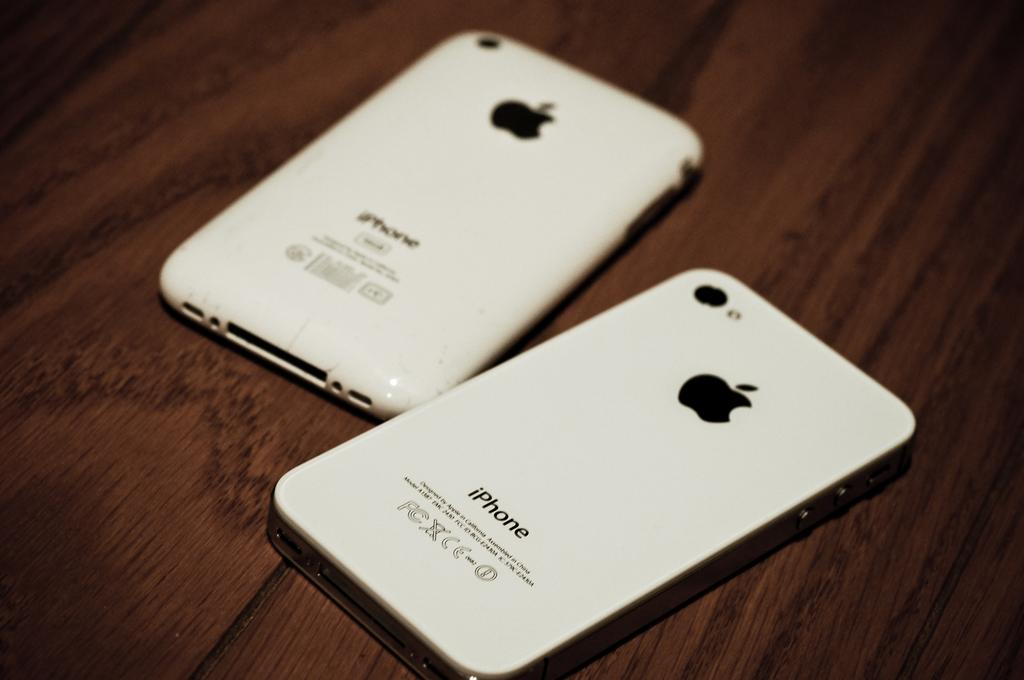Provide a one-sentence caption for the provided image. Two iphones are flipped upside down on a wooden table. 